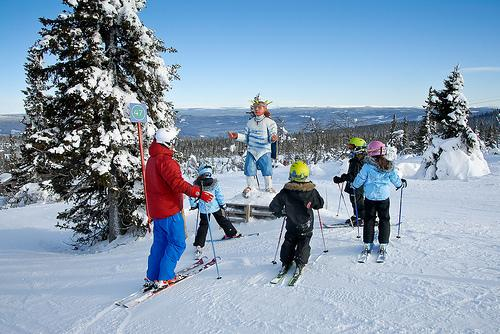What types of trees can be seen in the image and describe their condition. There are snowy evergreen trees and a snow-covered pine tree, with one having a lot of snow at the base. List the safety gear worn by the children in the image. The children are wearing yellow, white, and pink skiing helmets. Describe the position of the skies and their appearance in the image. There are ski marks in the snow, as well as a child wearing black pants is on skis. What are the three main colors of the skier's attire? The three main colors are red, blue, and black. Identify the distinct clothing worn by the skier in the image. The skier is wearing a red jacket, blue pants, a yellow helmet, black ski pants, and a light blue sweater. Describe the weather and landscape in the image. It's a clear blue, daytime sky with no clouds, a snow-covered ground, and a blue valley on the horizon. Talk about the unique figure or object positioned in the snowy landscape. There is a statue of a person on a snowy mound, possibly on a mountain, and seems to be attracting attention. Describe the scene related to the Christmas tree in the image. There is a snow-covered evergreen tree that resembles a Christmas tree with snow on its branches. Provide a short description of the group of people in the image. A group of people, including one adult and four children, are preparing to ski and are wearing safety helmets. Mention what is written on the sign and describe its appearance. The sign says "47" and it is blue, white, and yellow, attached to a red pole. 